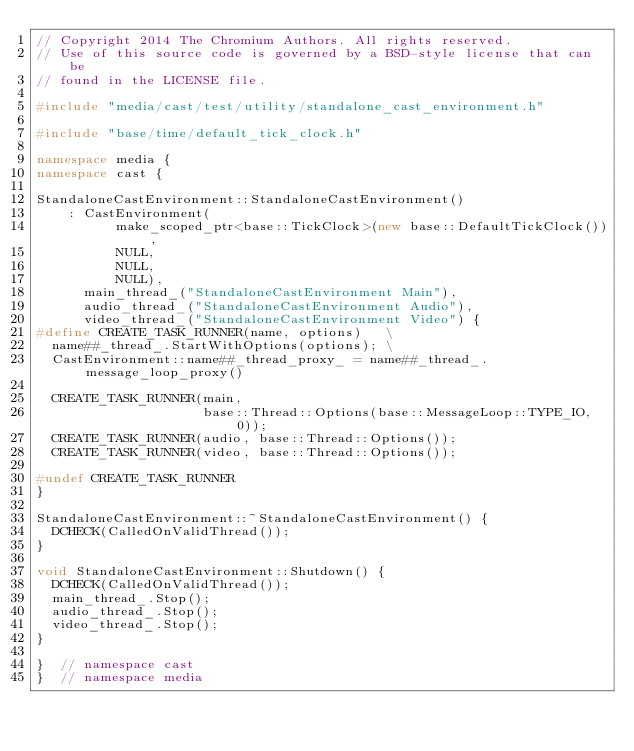<code> <loc_0><loc_0><loc_500><loc_500><_C++_>// Copyright 2014 The Chromium Authors. All rights reserved.
// Use of this source code is governed by a BSD-style license that can be
// found in the LICENSE file.

#include "media/cast/test/utility/standalone_cast_environment.h"

#include "base/time/default_tick_clock.h"

namespace media {
namespace cast {

StandaloneCastEnvironment::StandaloneCastEnvironment()
    : CastEnvironment(
          make_scoped_ptr<base::TickClock>(new base::DefaultTickClock()),
          NULL,
          NULL,
          NULL),
      main_thread_("StandaloneCastEnvironment Main"),
      audio_thread_("StandaloneCastEnvironment Audio"),
      video_thread_("StandaloneCastEnvironment Video") {
#define CREATE_TASK_RUNNER(name, options)   \
  name##_thread_.StartWithOptions(options); \
  CastEnvironment::name##_thread_proxy_ = name##_thread_.message_loop_proxy()

  CREATE_TASK_RUNNER(main,
                     base::Thread::Options(base::MessageLoop::TYPE_IO, 0));
  CREATE_TASK_RUNNER(audio, base::Thread::Options());
  CREATE_TASK_RUNNER(video, base::Thread::Options());

#undef CREATE_TASK_RUNNER
}

StandaloneCastEnvironment::~StandaloneCastEnvironment() {
  DCHECK(CalledOnValidThread());
}

void StandaloneCastEnvironment::Shutdown() {
  DCHECK(CalledOnValidThread());
  main_thread_.Stop();
  audio_thread_.Stop();
  video_thread_.Stop();
}

}  // namespace cast
}  // namespace media
</code> 